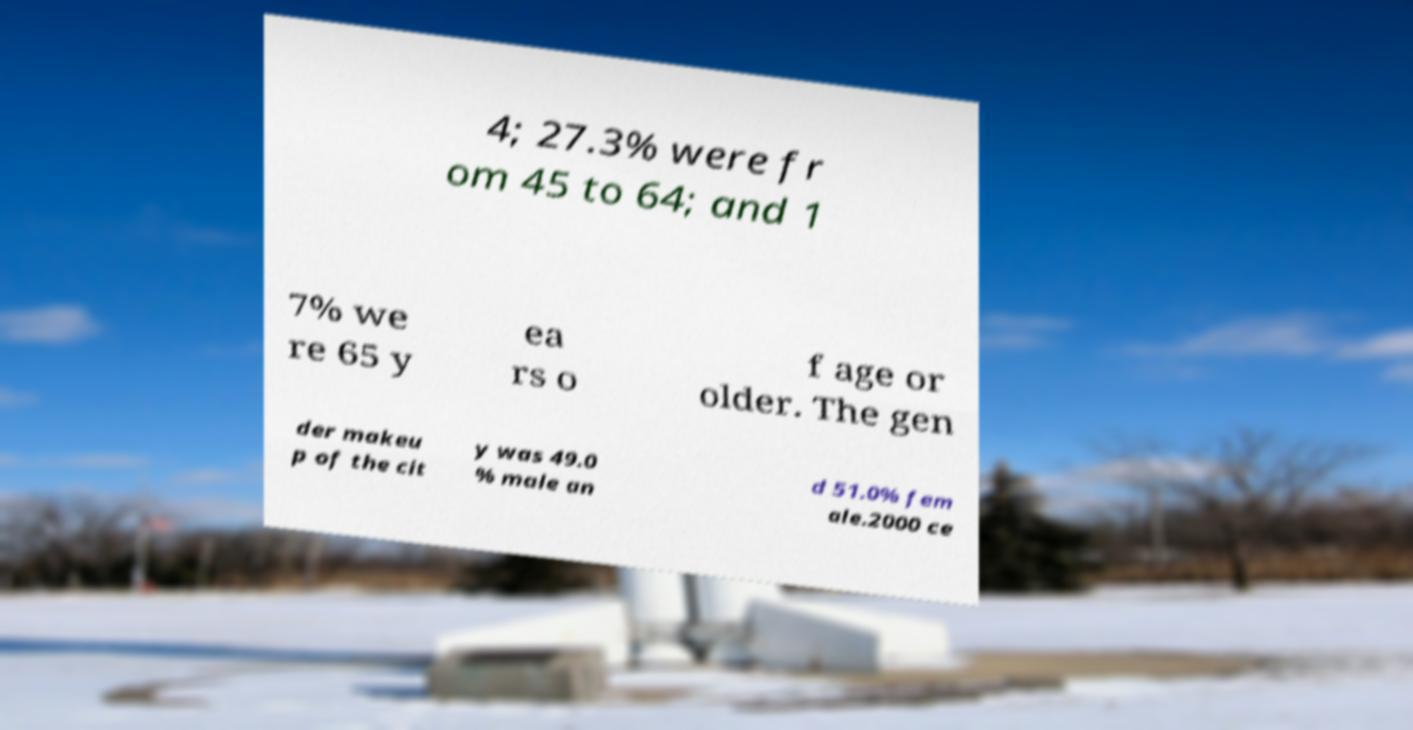What messages or text are displayed in this image? I need them in a readable, typed format. 4; 27.3% were fr om 45 to 64; and 1 7% we re 65 y ea rs o f age or older. The gen der makeu p of the cit y was 49.0 % male an d 51.0% fem ale.2000 ce 